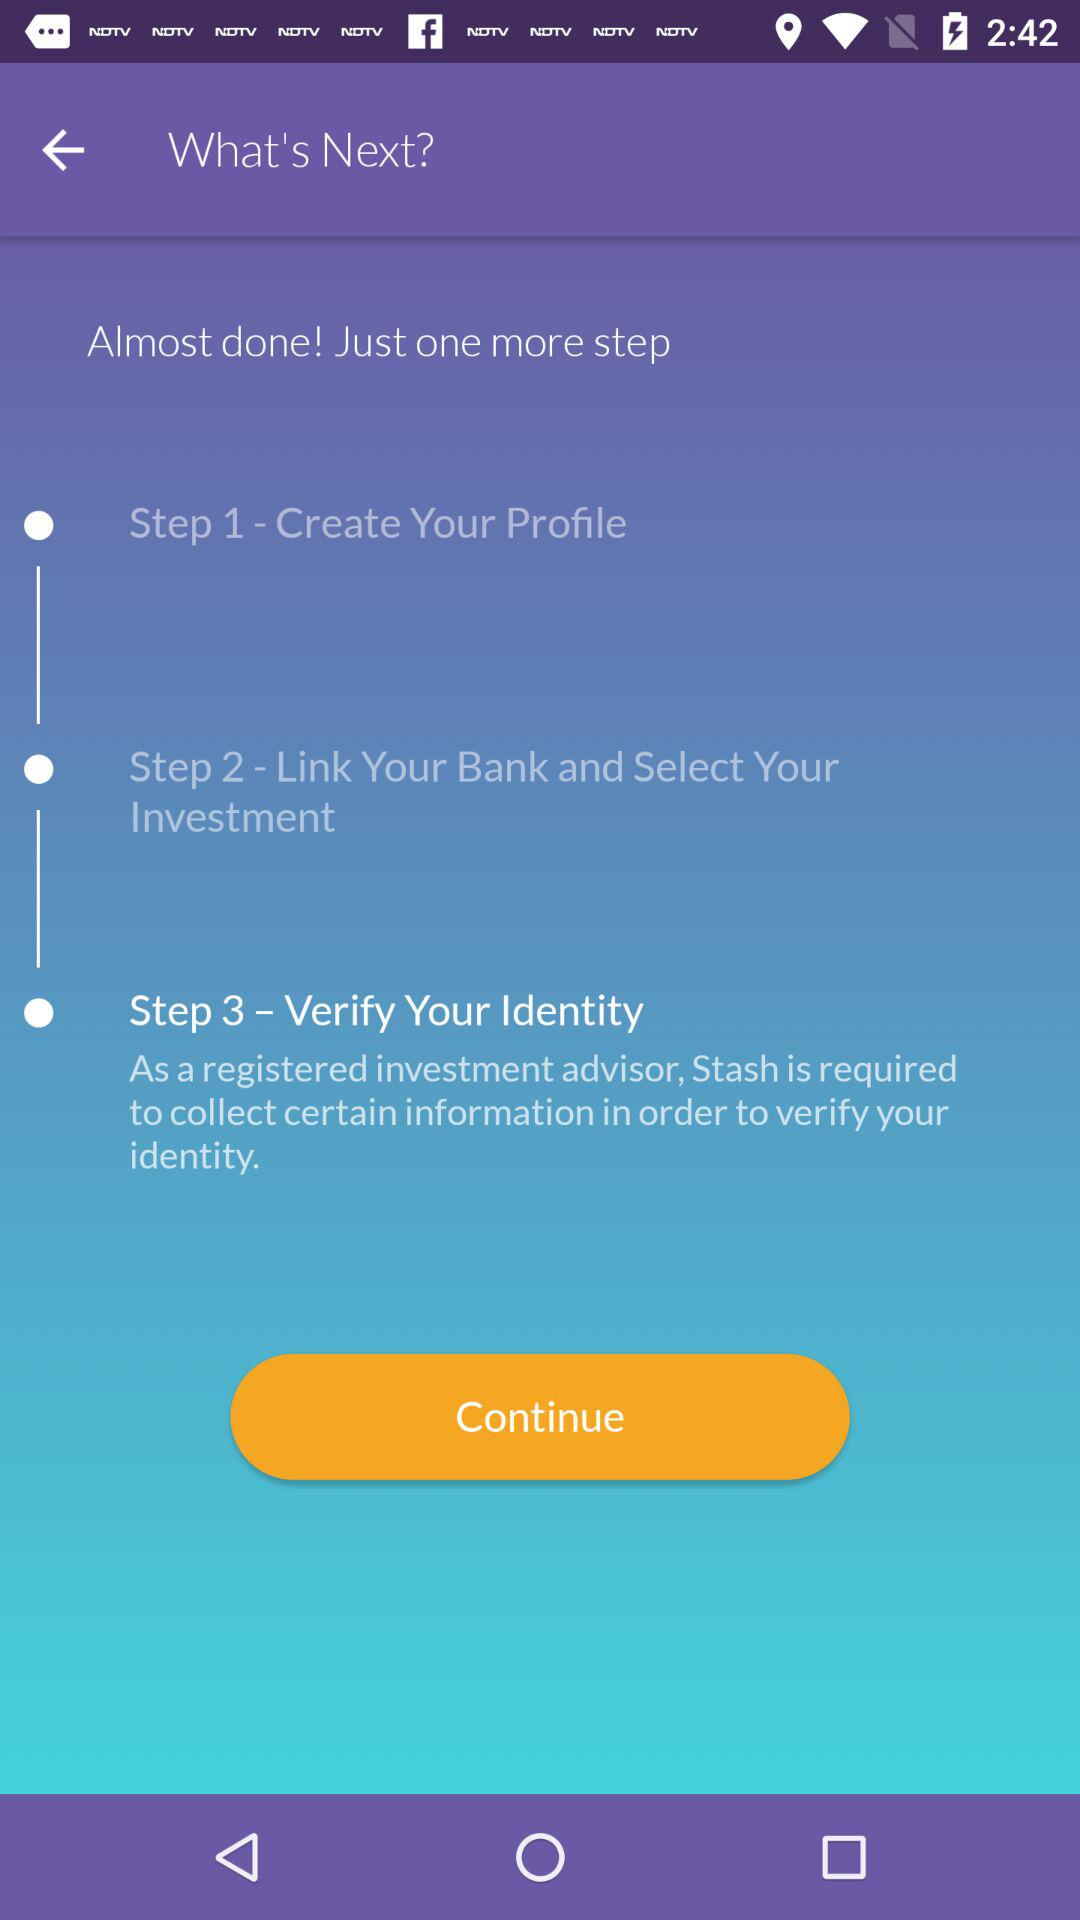How many more steps do I have left?
Answer the question using a single word or phrase. 1 